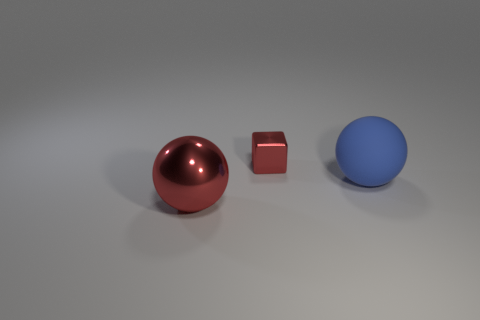There is a block; does it have the same color as the ball that is on the right side of the large red sphere? The block in the image does not share the same color as the ball to the right of the large red sphere. The block appears to have a red hue, while the ball on the right has a distinct blue color, making them quite different in appearance. 